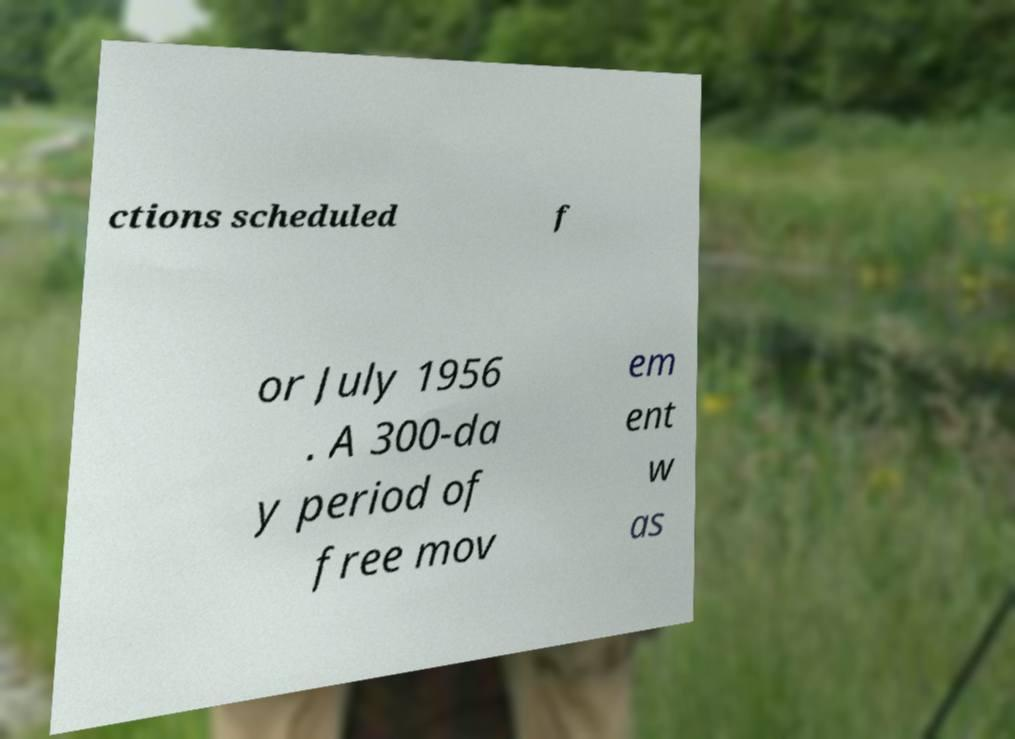Could you extract and type out the text from this image? ctions scheduled f or July 1956 . A 300-da y period of free mov em ent w as 